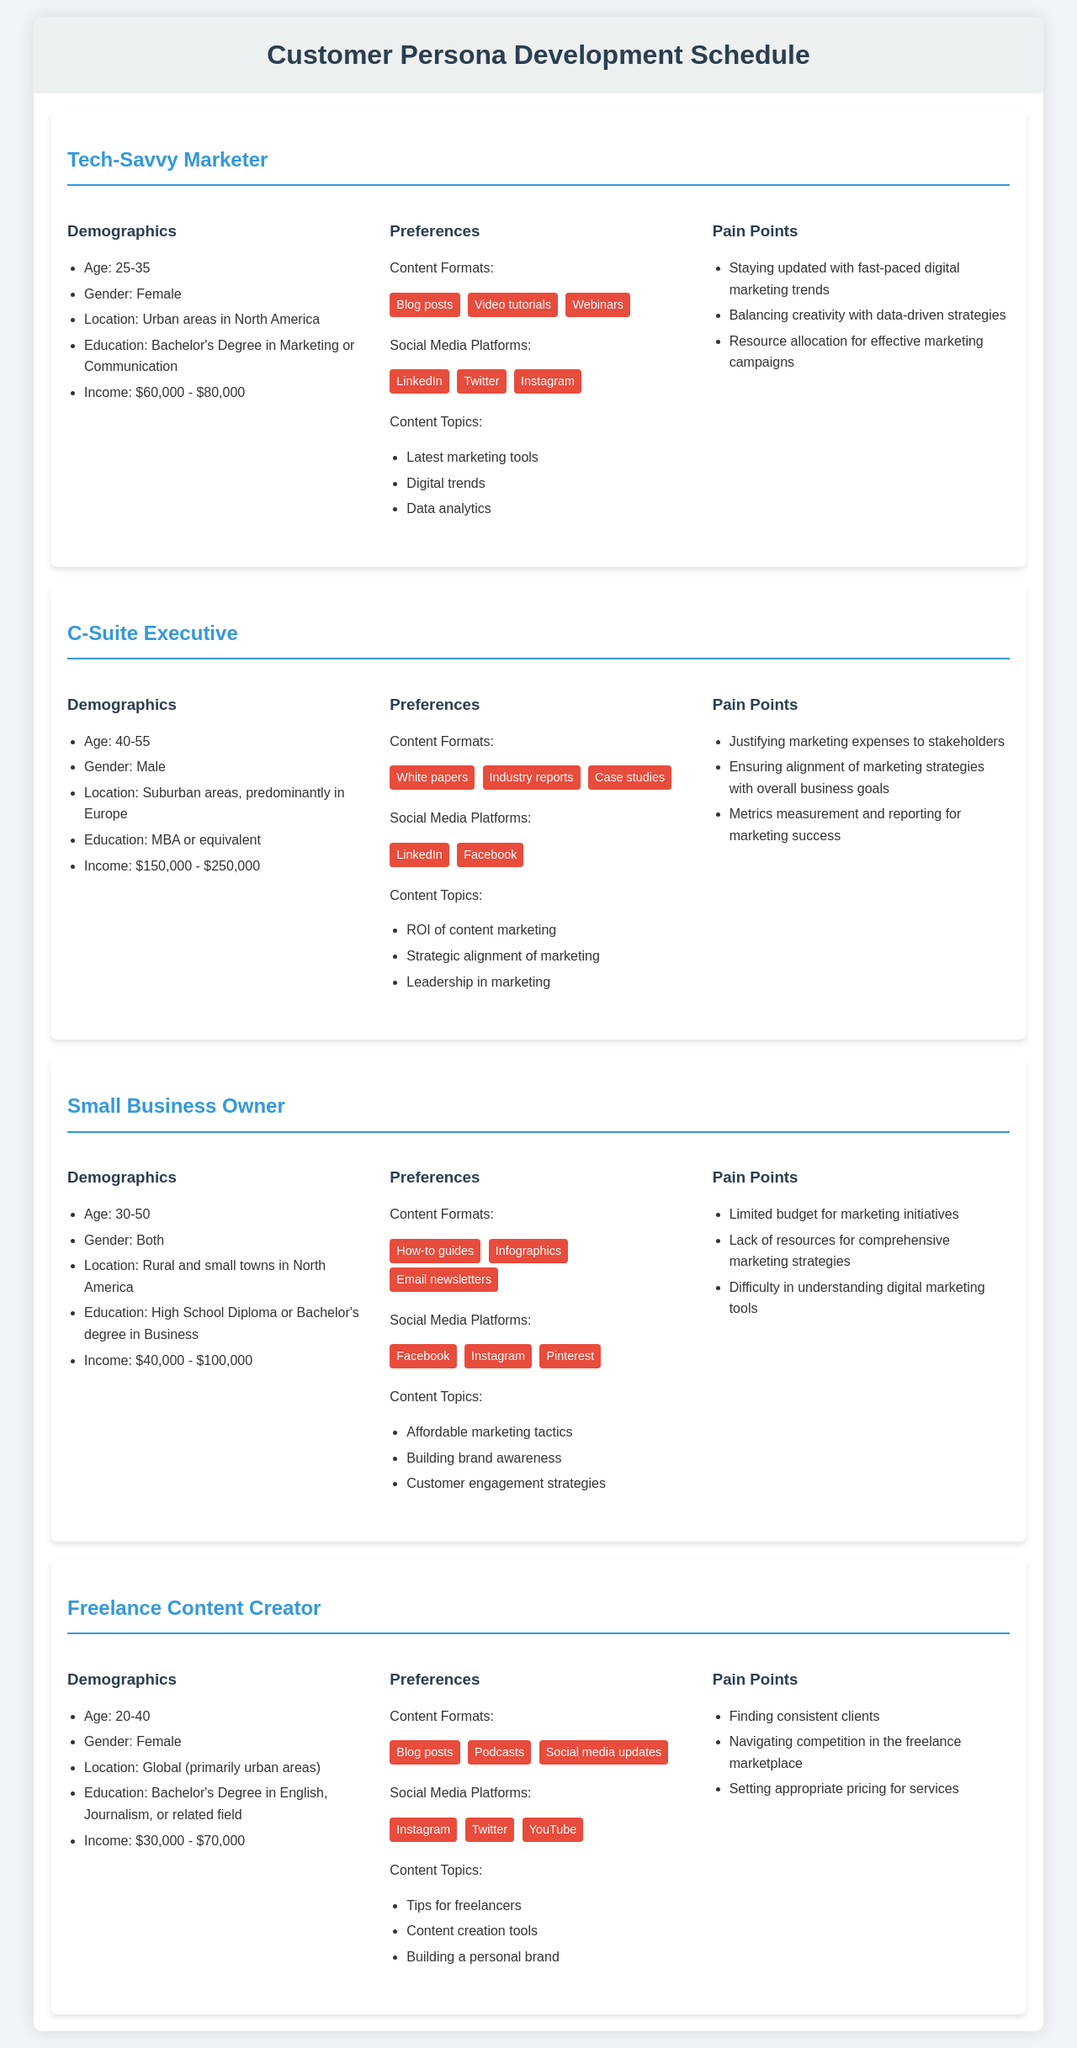What is the age range for the Tech-Savvy Marketer persona? The age range for the Tech-Savvy Marketer persona is stated in the demographics section.
Answer: 25-35 What is the income range for the Small Business Owner persona? The income range for the Small Business Owner persona is mentioned in the demographics section.
Answer: $40,000 - $100,000 Which social media platform is preferred by C-Suite Executives? The preferred social media platforms for C-Suite Executives are listed under the preferences section.
Answer: LinkedIn What is a pain point for Freelance Content Creators? The pain points for Freelance Content Creators are outlined in the pain points section of their persona.
Answer: Finding consistent clients What content format do Tech-Savvy Marketers prefer? The preferred content formats for Tech-Savvy Marketers are specified in the preferences section.
Answer: Blog posts How many personas are displayed in the document? The total number of personas can be counted from the document's headings.
Answer: Four What content topics are associated with the Small Business Owner persona? The content topics for Small Business Owners are highlighted in the preferences section of their persona.
Answer: Affordable marketing tactics, Building brand awareness, Customer engagement strategies What is the gender of the Freelance Content Creator persona? The gender of the Freelance Content Creator is provided in the demographics section.
Answer: Female 